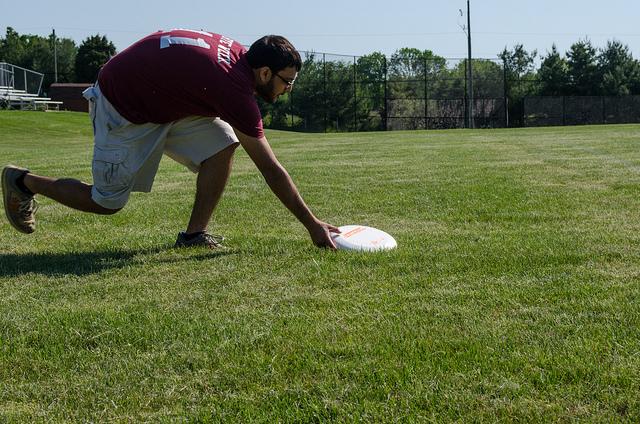How many blades of grass is the frisbee on?
Write a very short answer. 100. Does a gopher live nearby?
Give a very brief answer. No. What is on the man's shirt?
Quick response, please. 11. What number is on the man's shirt?
Quick response, please. 11. What is the color of the freebee?
Give a very brief answer. White. What is the man playing with?
Quick response, please. Frisbee. Is the man on the right holding the frisbee or actively passing it to the man on the left?
Concise answer only. Holding. 